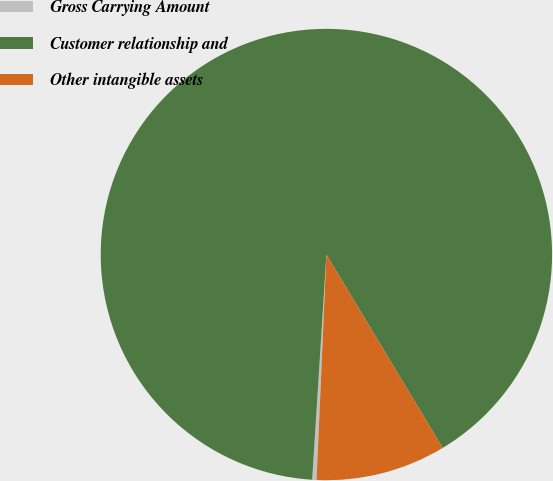Convert chart to OTSL. <chart><loc_0><loc_0><loc_500><loc_500><pie_chart><fcel>Gross Carrying Amount<fcel>Customer relationship and<fcel>Other intangible assets<nl><fcel>0.31%<fcel>90.38%<fcel>9.31%<nl></chart> 